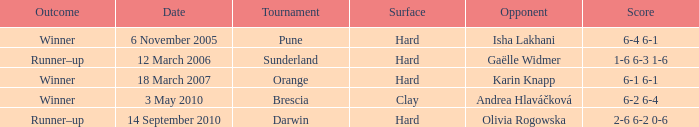What was the outcome of the competition against isha lakhani? 6-4 6-1. 